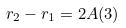<formula> <loc_0><loc_0><loc_500><loc_500>r _ { 2 } - r _ { 1 } = 2 A ( 3 )</formula> 